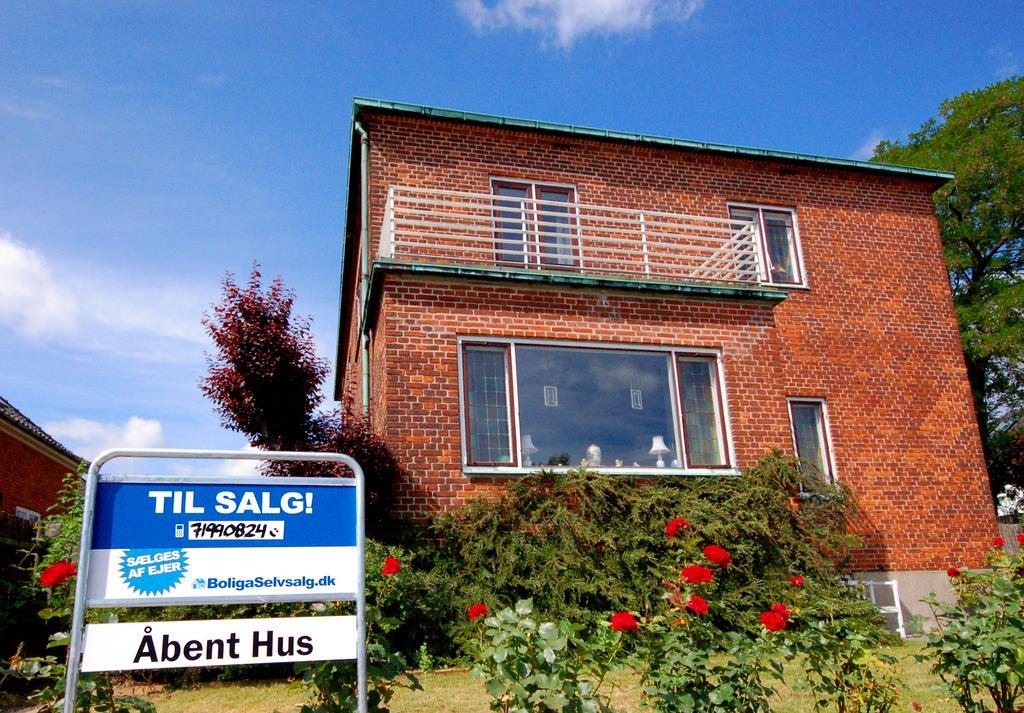Could you give a brief overview of what you see in this image? In the picture I can see buildings, trees, flower plants and a board which has something written on it. In the background I can see the sky. 